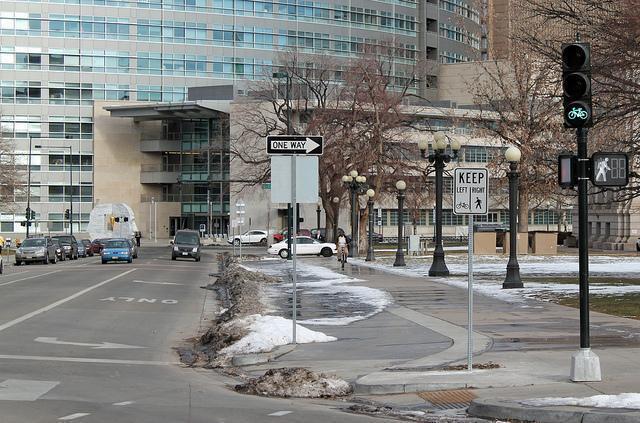What natural event seems to have occurred here?
Choose the right answer from the provided options to respond to the question.
Options: Hurricane, thunder, snow, tornado. Snow. 